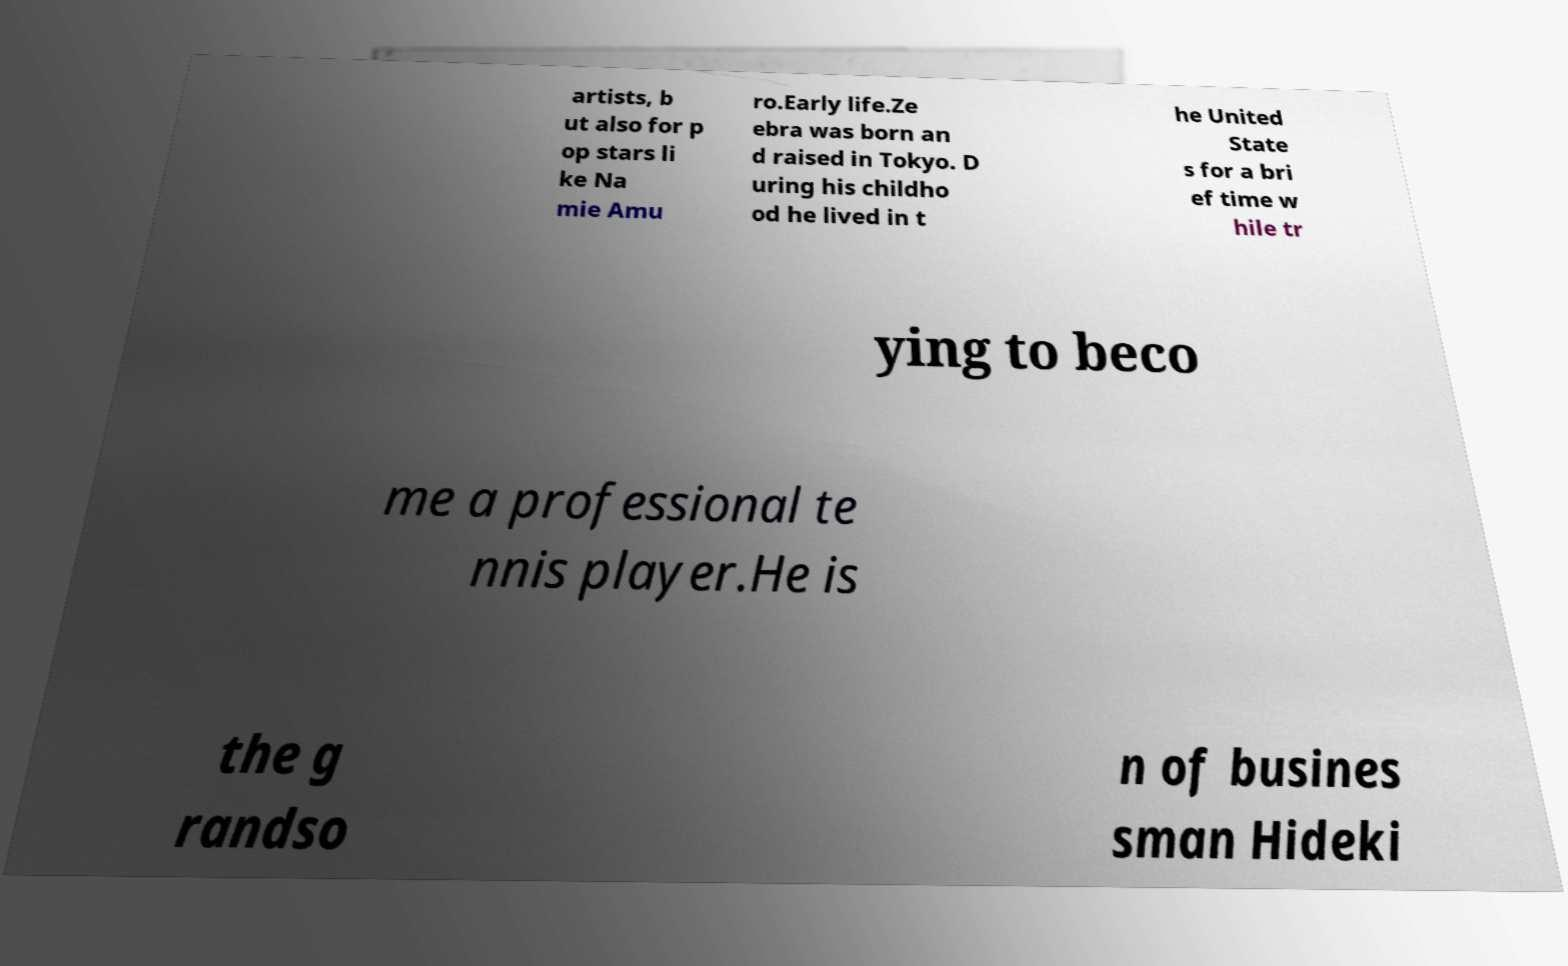Can you read and provide the text displayed in the image?This photo seems to have some interesting text. Can you extract and type it out for me? artists, b ut also for p op stars li ke Na mie Amu ro.Early life.Ze ebra was born an d raised in Tokyo. D uring his childho od he lived in t he United State s for a bri ef time w hile tr ying to beco me a professional te nnis player.He is the g randso n of busines sman Hideki 